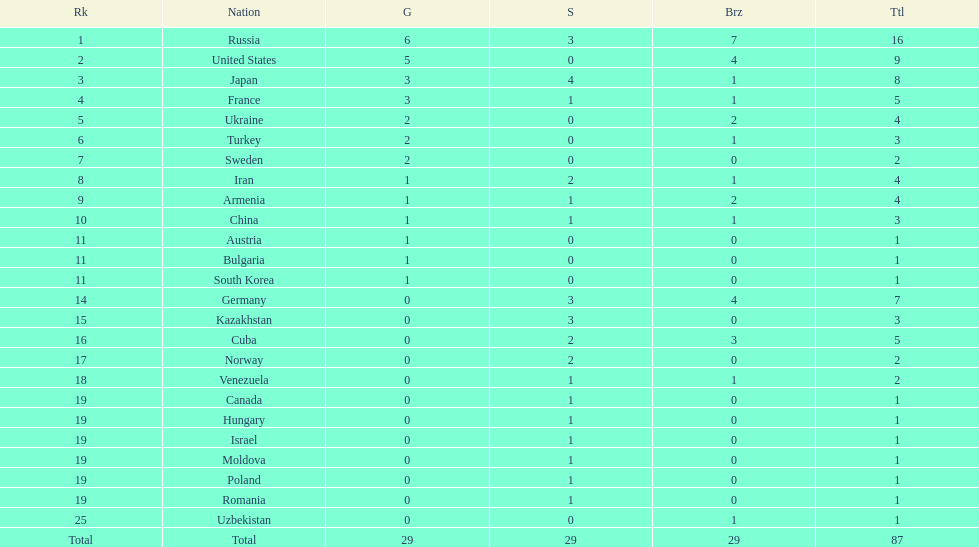Which nation was not in the top 10 iran or germany? Germany. 